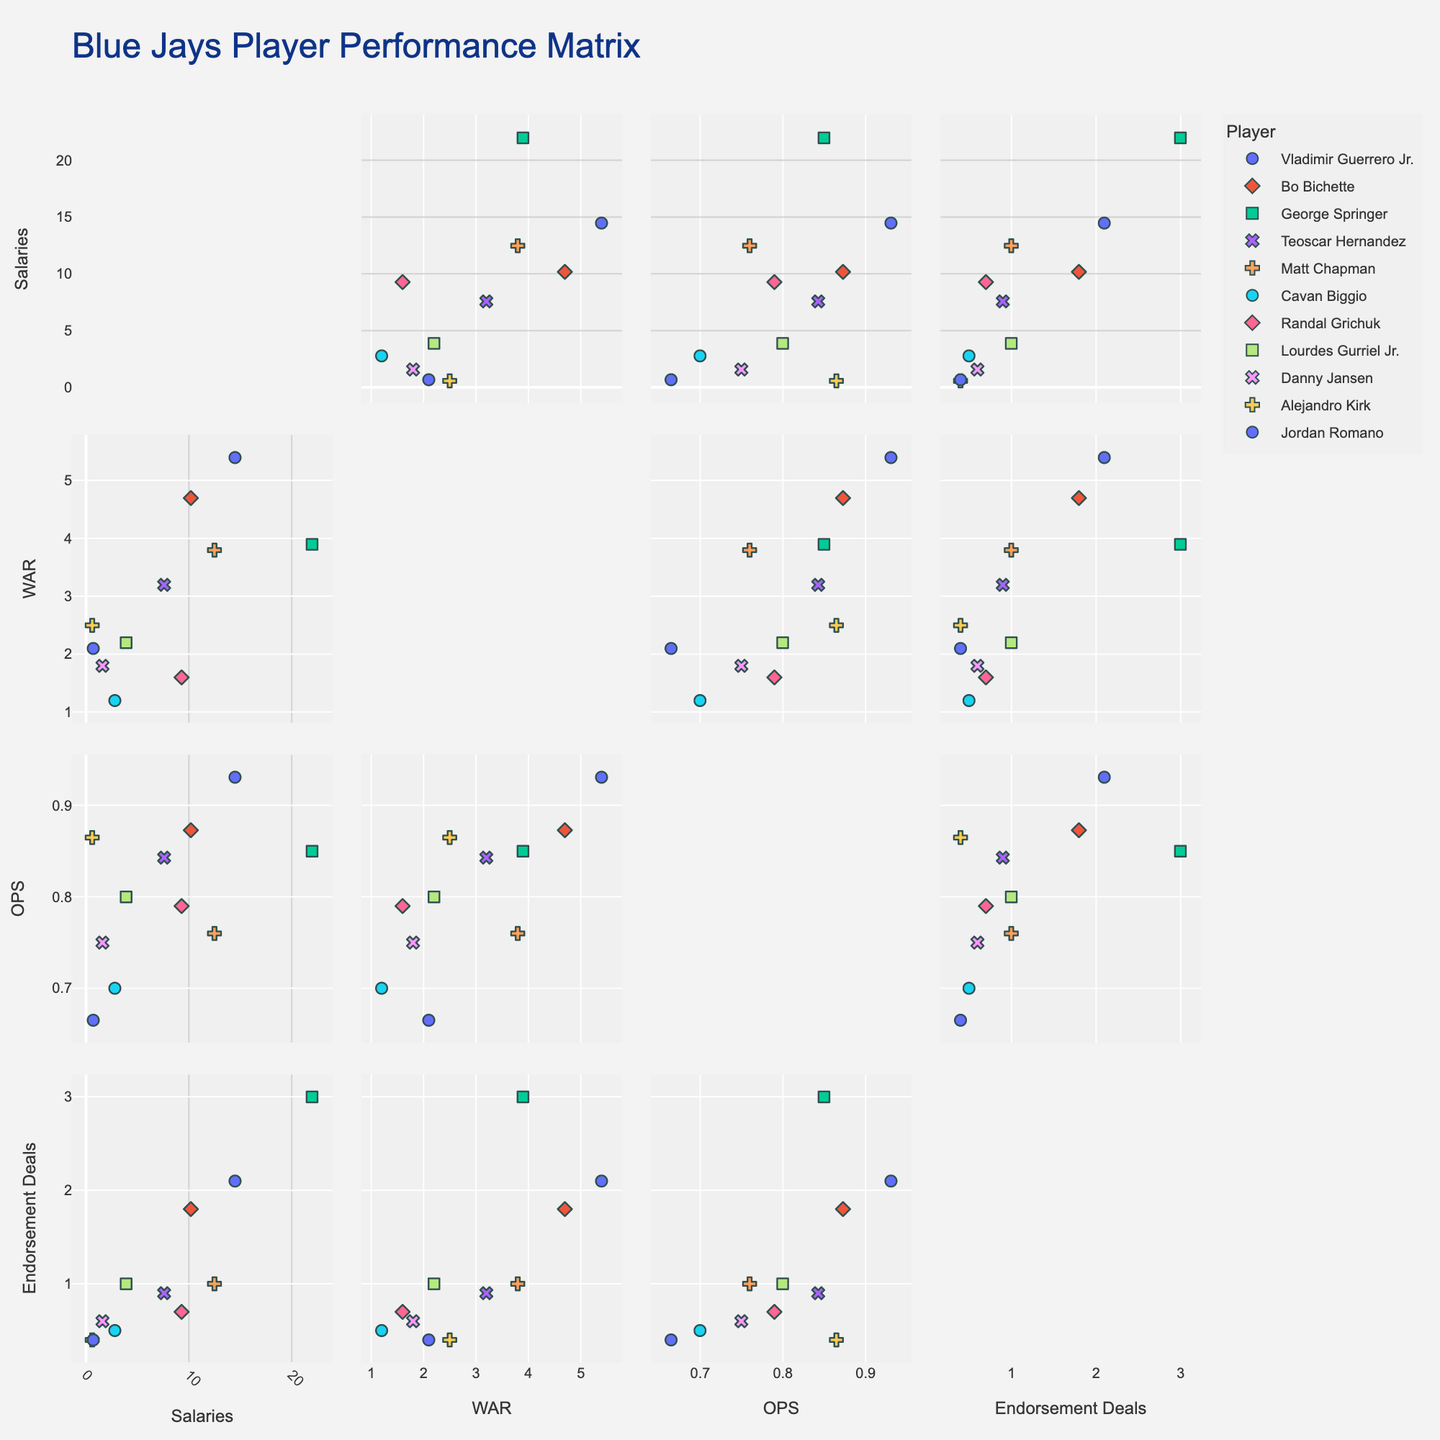Which player has the highest WAR? To find this, look for the data point with the highest value on the WAR axis. The Player dimension helps identify the corresponding name.
Answer: Vladimir Guerrero Jr What is the relationship between Salaries and WAR for George Springer? Find George Springer's data points on the scatter plot matrix. Compare his Salaries and WAR values.
Answer: George Springer has a Salaries($M) of 22.0 and a WAR of 3.9 Are higher salaries associated with higher endorsement deals? Observe the trend between the Salaries and Endorsement Deals axes. Look for a pattern where higher salaries correspond with higher endorsement values.
Answer: Generally, yes Which player has the lowest OPS and what is it? Identify the data point with the lowest value on the OPS axis and use the Player dimension to find the corresponding player.
Answer: Jordan Romano, 0.665 OPS Compare the endorsement deals and WAR for Bo Bichette and Teoscar Hernandez. Find the data points for Bo Bichette and Teoscar Hernandez on the scatter plot matrix. Compare their respective endorsement deals and WAR values.
Answer: Bo Bichette: 1.8M endorsement deals, 4.7 WAR; Teoscar Hernandez: 0.9M endorsement deals, 3.2 WAR Which player earns more in endorsements: Vladimir Guerrero Jr. or George Springer? Look at the data points for Vladimir Guerrero Jr. and George Springer in the Endorsement Deals axis. Compare their values.
Answer: George Springer (3.0M) earns more than Vladimir Guerrero Jr. (2.1M) What is the overall trend between the values of OPS and WAR? By studying the scatter plot matrix sections comparing OPS and WAR, observe if there is a positive, negative, or no clear trend.
Answer: Positive trend How does Matt Chapman's WAR compare to his OPS? Look for Matt Chapman's data points in the sections for WAR and OPS. Compare the values directly.
Answer: Matt Chapman has a WAR of 3.8 and an OPS of 0.760 What is the total salary for all players combined? Sum up the Salaries($M) values for all players. Adding up 14.5, 10.2, 22.0, 7.6, 12.5, 2.8, 9.3, 3.9, 1.6, 0.6, and 0.7M.
Answer: 85.7M Is there any player who has both a relatively high WAR and a relatively low salary? If so, who? Look for players whose WAR values are high but who do not have high salaries. Identify any such player.
Answer: Alejandro Kirk (HIGH WAR of 2.5 and LOW salary of 0.6M) 